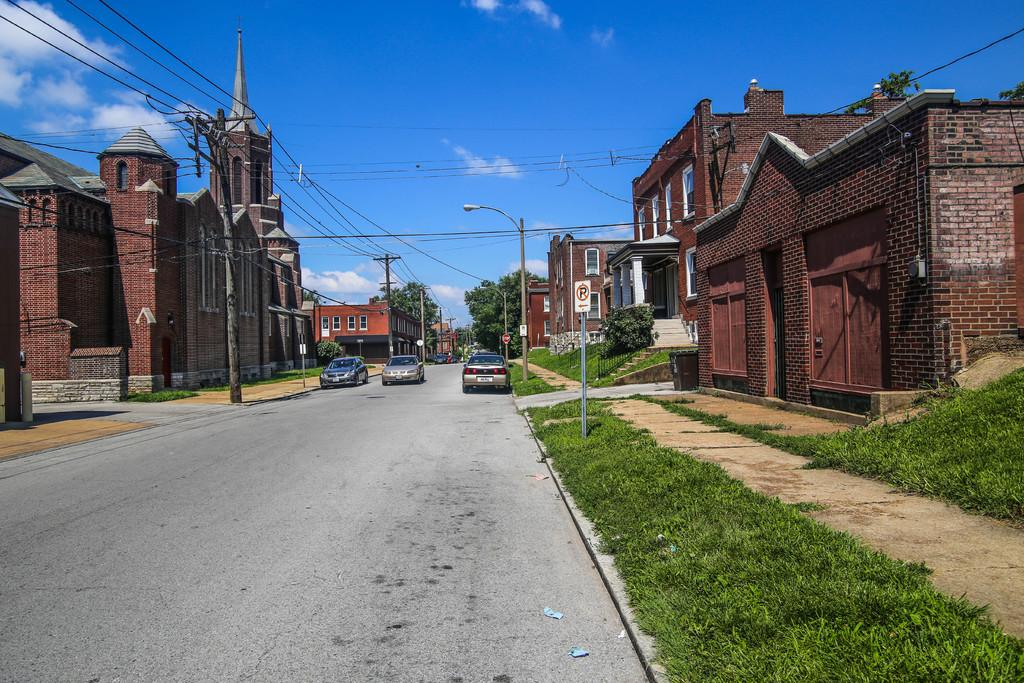<image>
Relay a brief, clear account of the picture shown. Brick buildings line the streets with a red stop sign in the background. 